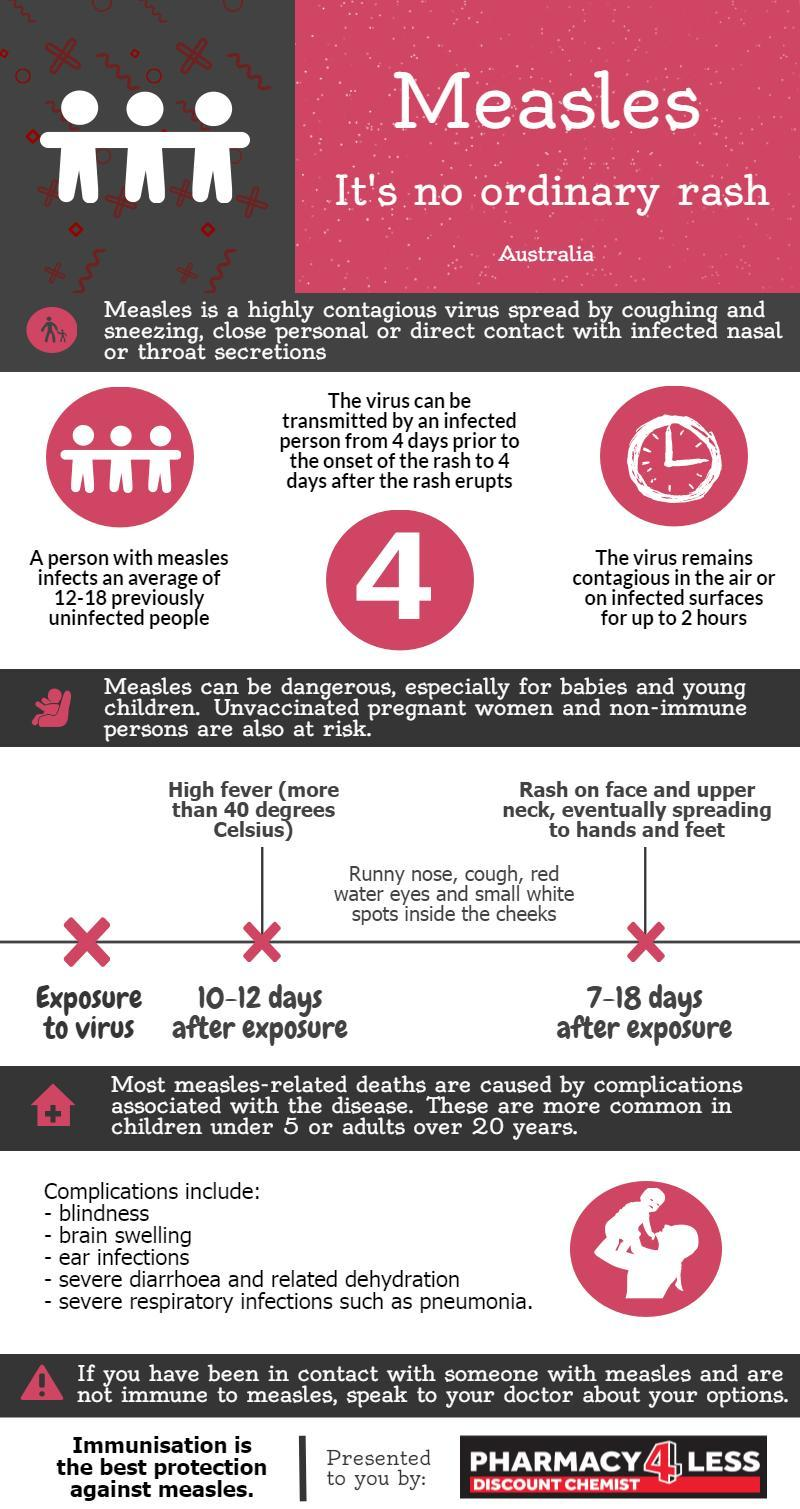How many days after the entry of measles virus rashes appear on face and neck?
Answer the question with a short phrase. 7-18 days What is the second complication of Measles listed in the infographic? brain swelling Which category of people need to be extremely careful against Measles? Unvaccinated pregnant women and non-immune persons How many persons can get Measles from a Measles affected person? 12-18 For how long the Measles virus stay in the air? up to 2 hours What is the fourth complication of Measles listed in the infographic? severe diarrhoea and related dehydration 